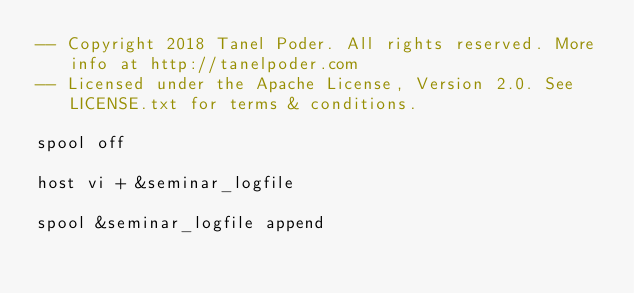Convert code to text. <code><loc_0><loc_0><loc_500><loc_500><_SQL_>-- Copyright 2018 Tanel Poder. All rights reserved. More info at http://tanelpoder.com
-- Licensed under the Apache License, Version 2.0. See LICENSE.txt for terms & conditions.

spool off

host vi + &seminar_logfile

spool &seminar_logfile append

</code> 